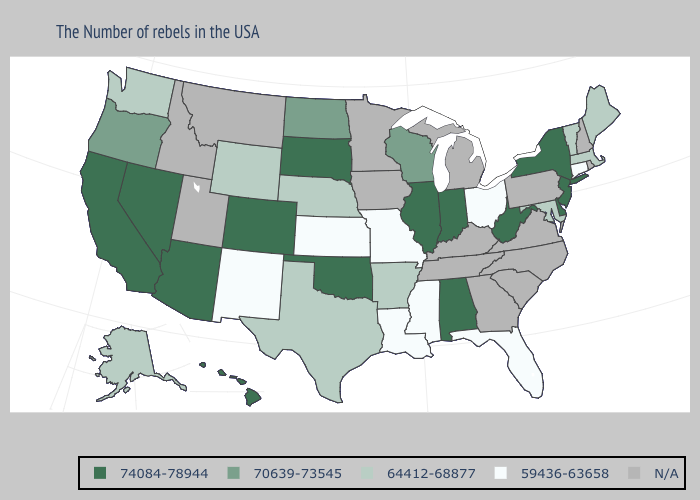How many symbols are there in the legend?
Keep it brief. 5. Name the states that have a value in the range N/A?
Answer briefly. Rhode Island, New Hampshire, Pennsylvania, Virginia, North Carolina, South Carolina, Georgia, Michigan, Kentucky, Tennessee, Minnesota, Iowa, Utah, Montana, Idaho. Name the states that have a value in the range 59436-63658?
Quick response, please. Connecticut, Ohio, Florida, Mississippi, Louisiana, Missouri, Kansas, New Mexico. Name the states that have a value in the range 64412-68877?
Concise answer only. Maine, Massachusetts, Vermont, Maryland, Arkansas, Nebraska, Texas, Wyoming, Washington, Alaska. What is the value of Washington?
Answer briefly. 64412-68877. Name the states that have a value in the range 64412-68877?
Concise answer only. Maine, Massachusetts, Vermont, Maryland, Arkansas, Nebraska, Texas, Wyoming, Washington, Alaska. What is the value of Delaware?
Be succinct. 74084-78944. What is the value of Maine?
Concise answer only. 64412-68877. What is the value of New York?
Be succinct. 74084-78944. What is the highest value in the USA?
Quick response, please. 74084-78944. Which states have the highest value in the USA?
Be succinct. New York, New Jersey, Delaware, West Virginia, Indiana, Alabama, Illinois, Oklahoma, South Dakota, Colorado, Arizona, Nevada, California, Hawaii. Among the states that border Arkansas , which have the lowest value?
Keep it brief. Mississippi, Louisiana, Missouri. What is the value of New Jersey?
Short answer required. 74084-78944. Name the states that have a value in the range 64412-68877?
Write a very short answer. Maine, Massachusetts, Vermont, Maryland, Arkansas, Nebraska, Texas, Wyoming, Washington, Alaska. Name the states that have a value in the range 74084-78944?
Be succinct. New York, New Jersey, Delaware, West Virginia, Indiana, Alabama, Illinois, Oklahoma, South Dakota, Colorado, Arizona, Nevada, California, Hawaii. 